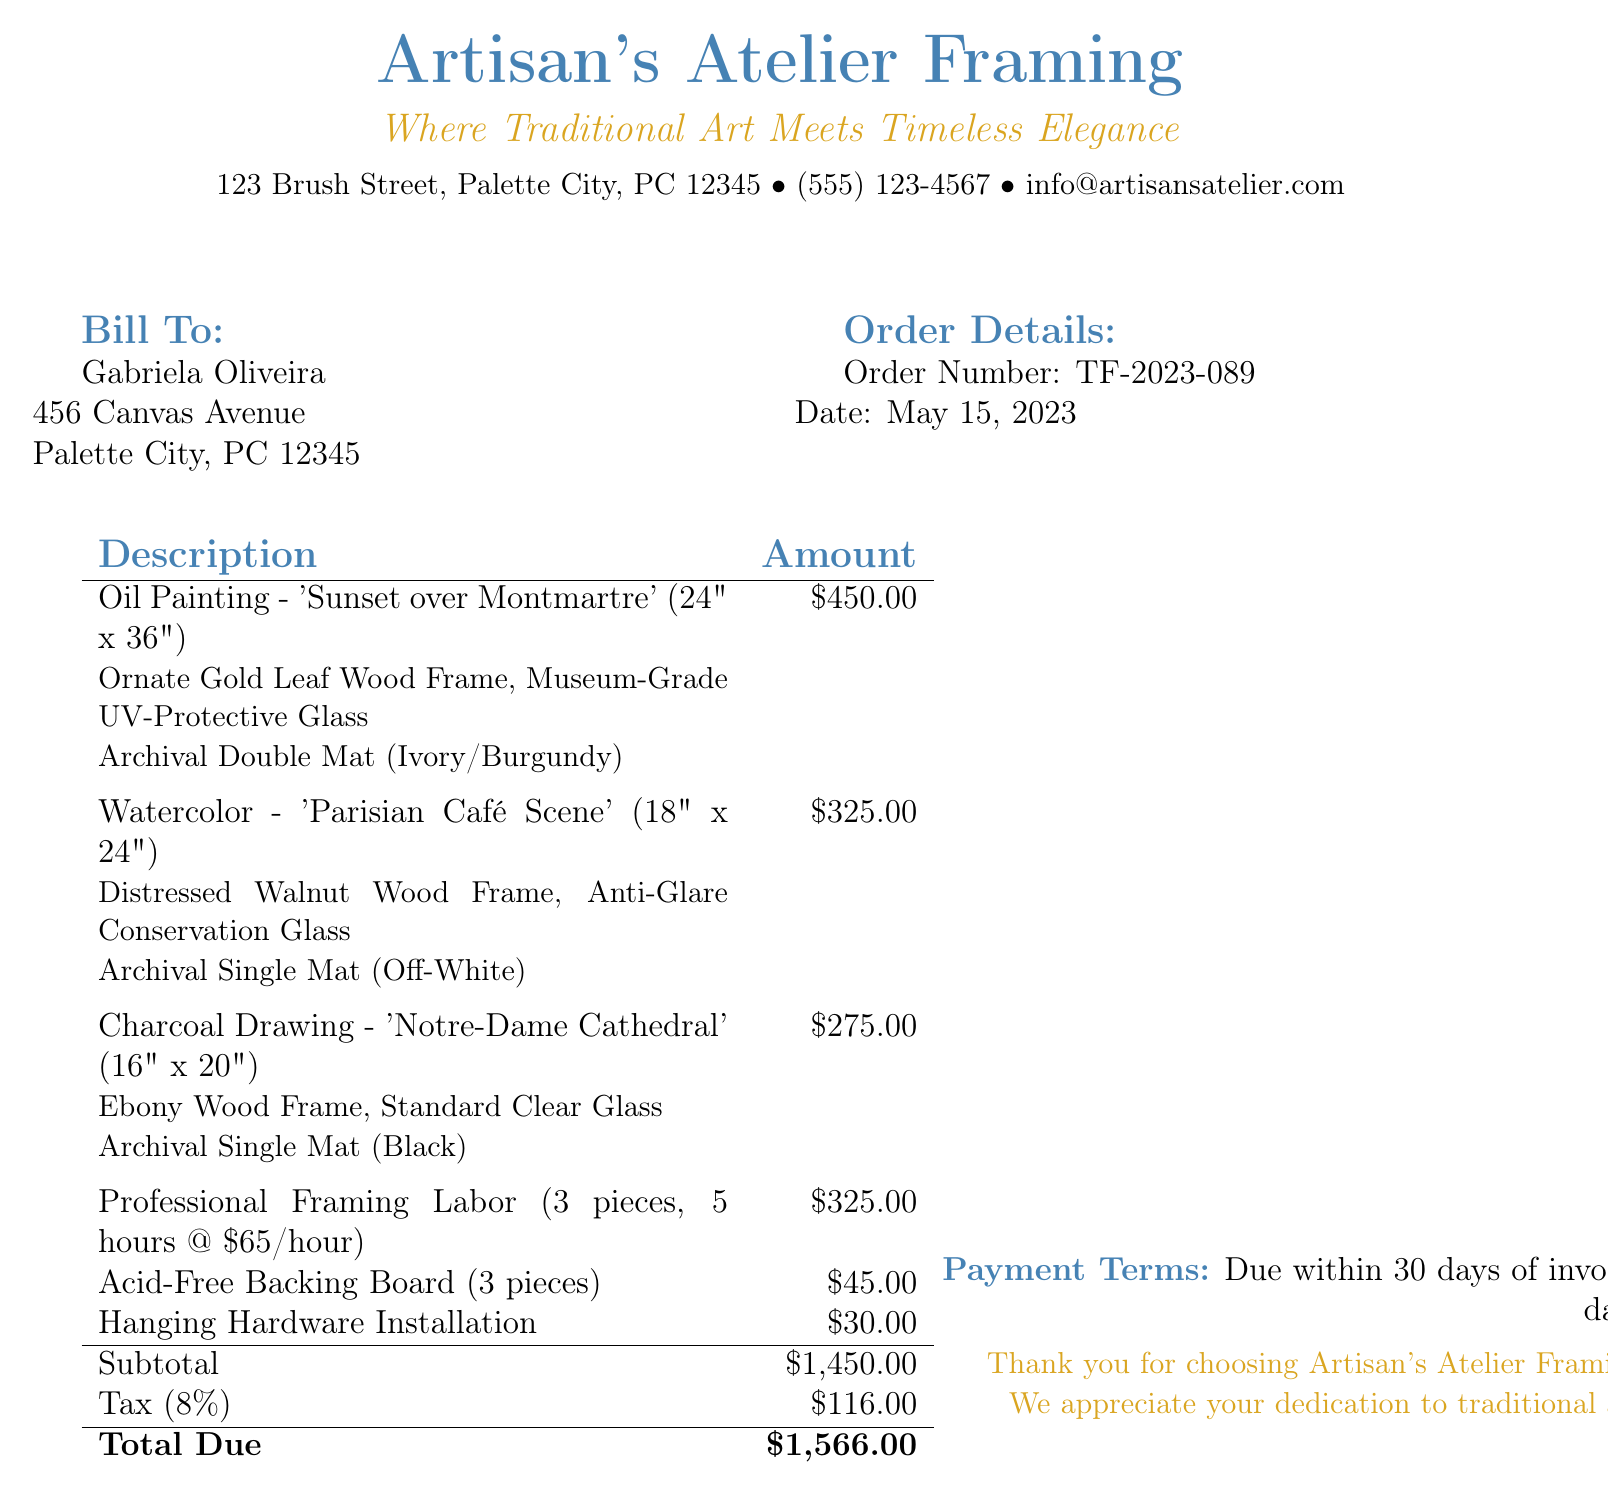What is the order number? The order number is listed under the order details section, which is TF-2023-089.
Answer: TF-2023-089 Who is the bill addressed to? The bill is addressed to the person listed under "Bill To," which is Gabriela Oliveira.
Answer: Gabriela Oliveira What is the subtotal amount? The subtotal amount is specified in the financial summary section, which is \$1,450.00.
Answer: $1,450.00 How many pieces were framed? The number of pieces framed is indicated in the professional framing labor description, which mentions 3 pieces.
Answer: 3 pieces What type of glass is used for the 'Sunset over Montmartre' painting? The type of glass is mentioned in the description of the frame for the painting, which is Museum-Grade UV-Protective Glass.
Answer: Museum-Grade UV-Protective Glass What is the total due amount? The total due is presented at the end of the document, which totals \$1,566.00.
Answer: $1,566.00 What is the tax rate applied to the subtotal? The tax rate is presented in the financial summary section, which is 8%.
Answer: 8% What is the payment term stated in the document? The payment term is mentioned near the end, which indicates that it is due within 30 days of invoice date.
Answer: Due within 30 days of invoice date What type of frame is used for the 'Parisian Café Scene'? The frame type is described in the item details section for the painting, which is Distressed Walnut Wood Frame.
Answer: Distressed Walnut Wood Frame 